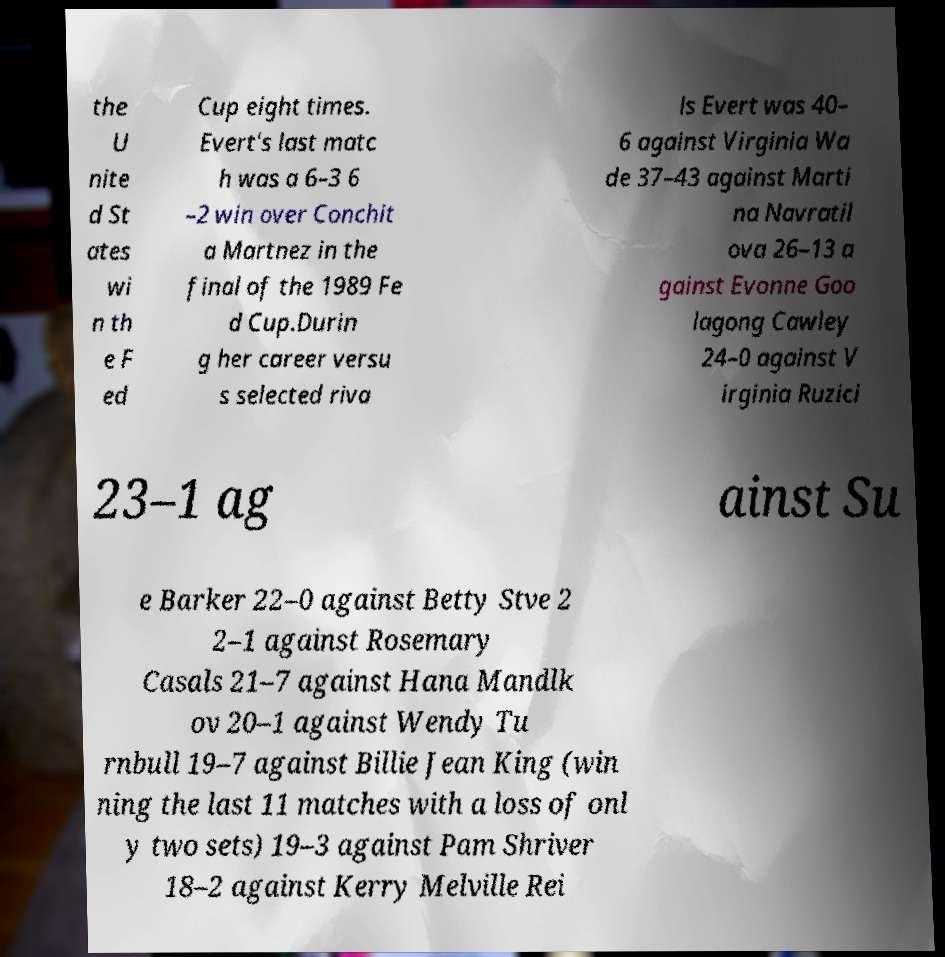There's text embedded in this image that I need extracted. Can you transcribe it verbatim? the U nite d St ates wi n th e F ed Cup eight times. Evert's last matc h was a 6–3 6 –2 win over Conchit a Martnez in the final of the 1989 Fe d Cup.Durin g her career versu s selected riva ls Evert was 40– 6 against Virginia Wa de 37–43 against Marti na Navratil ova 26–13 a gainst Evonne Goo lagong Cawley 24–0 against V irginia Ruzici 23–1 ag ainst Su e Barker 22–0 against Betty Stve 2 2–1 against Rosemary Casals 21–7 against Hana Mandlk ov 20–1 against Wendy Tu rnbull 19–7 against Billie Jean King (win ning the last 11 matches with a loss of onl y two sets) 19–3 against Pam Shriver 18–2 against Kerry Melville Rei 